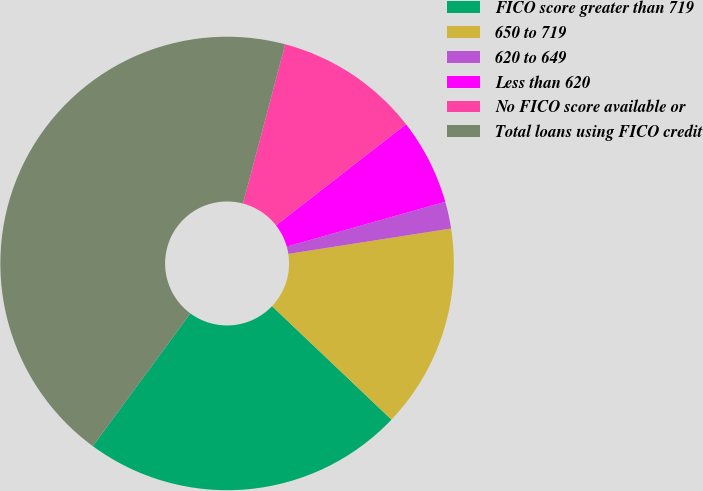Convert chart. <chart><loc_0><loc_0><loc_500><loc_500><pie_chart><fcel>FICO score greater than 719<fcel>650 to 719<fcel>620 to 649<fcel>Less than 620<fcel>No FICO score available or<fcel>Total loans using FICO credit<nl><fcel>23.0%<fcel>14.56%<fcel>1.92%<fcel>6.14%<fcel>10.35%<fcel>44.04%<nl></chart> 